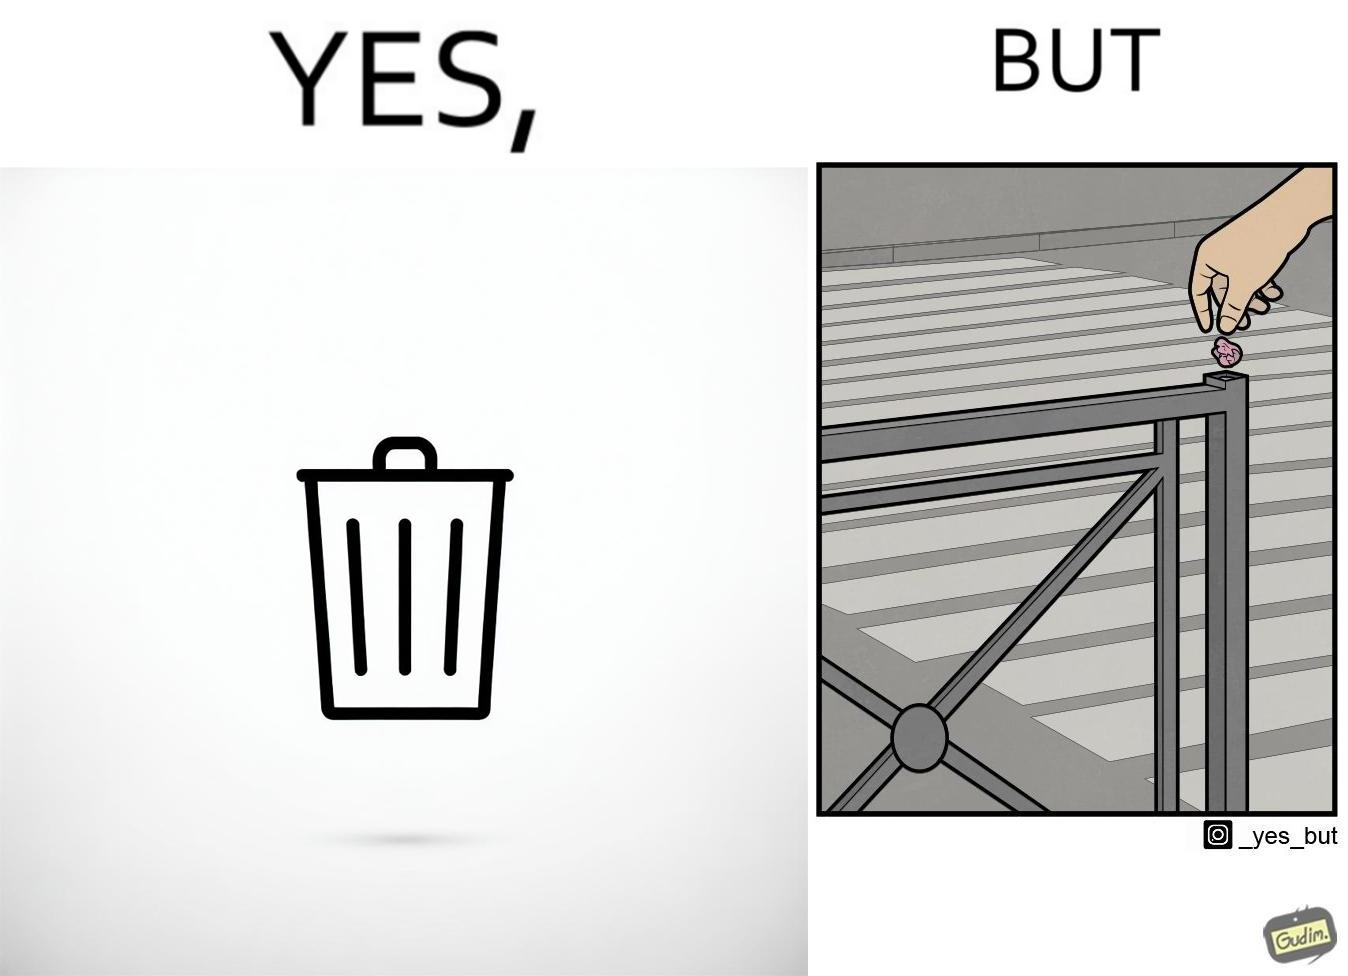What is shown in the left half versus the right half of this image? In the left part of the image: It is a garbage bin In the right part of the image: It is a human hand sticking chewing gum on public property 